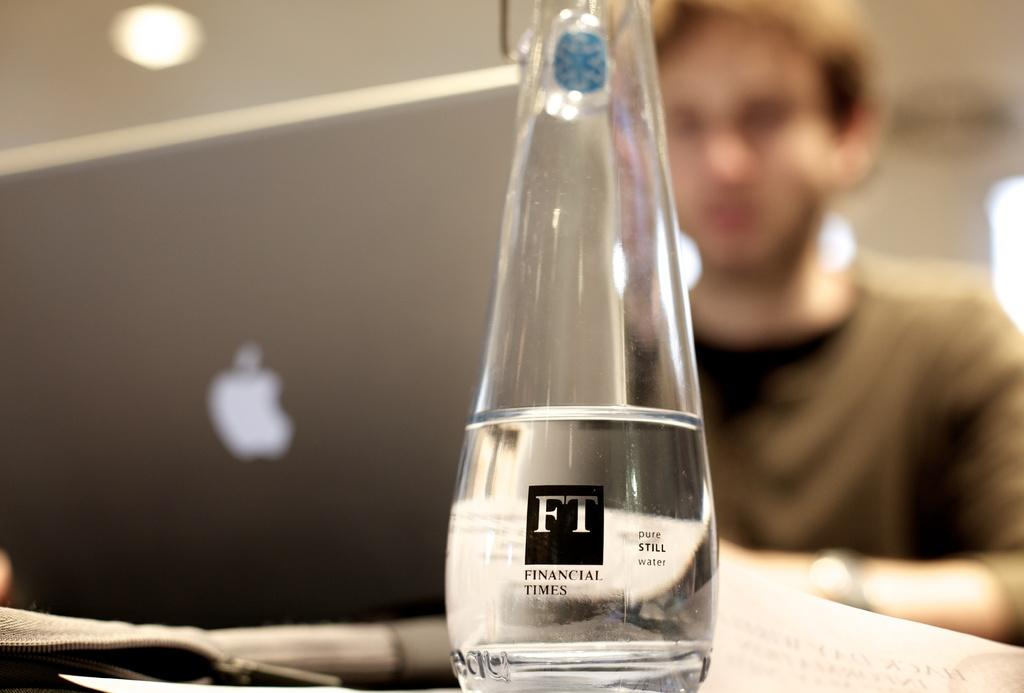<image>
Give a short and clear explanation of the subsequent image. A Man using a Mac computer in the background and a glass bottle with a "FT" logo in the foreground. 